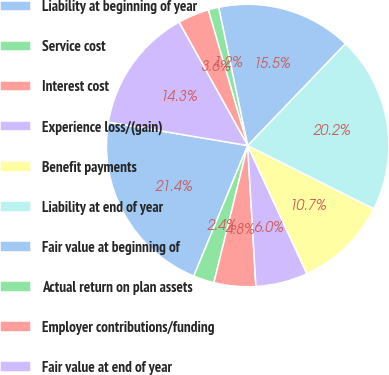<chart> <loc_0><loc_0><loc_500><loc_500><pie_chart><fcel>Liability at beginning of year<fcel>Service cost<fcel>Interest cost<fcel>Experience loss/(gain)<fcel>Benefit payments<fcel>Liability at end of year<fcel>Fair value at beginning of<fcel>Actual return on plan assets<fcel>Employer contributions/funding<fcel>Fair value at end of year<nl><fcel>21.42%<fcel>2.39%<fcel>4.77%<fcel>5.96%<fcel>10.71%<fcel>20.23%<fcel>15.47%<fcel>1.2%<fcel>3.58%<fcel>14.28%<nl></chart> 